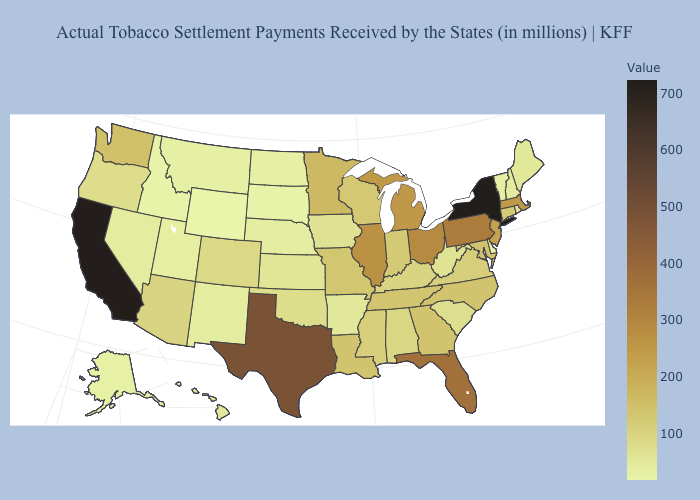Does the map have missing data?
Be succinct. No. Does Pennsylvania have a lower value than New York?
Concise answer only. Yes. Is the legend a continuous bar?
Write a very short answer. Yes. Which states hav the highest value in the South?
Short answer required. Texas. Does Connecticut have the highest value in the USA?
Concise answer only. No. 